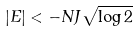Convert formula to latex. <formula><loc_0><loc_0><loc_500><loc_500>| E | < - N J \sqrt { \log 2 }</formula> 